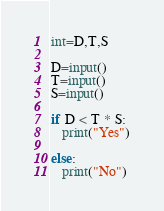<code> <loc_0><loc_0><loc_500><loc_500><_Python_>int=D,T,S

D=input()
T=input()
S=input()

if D < T * S:
   print("Yes")

else:
   print("No")</code> 